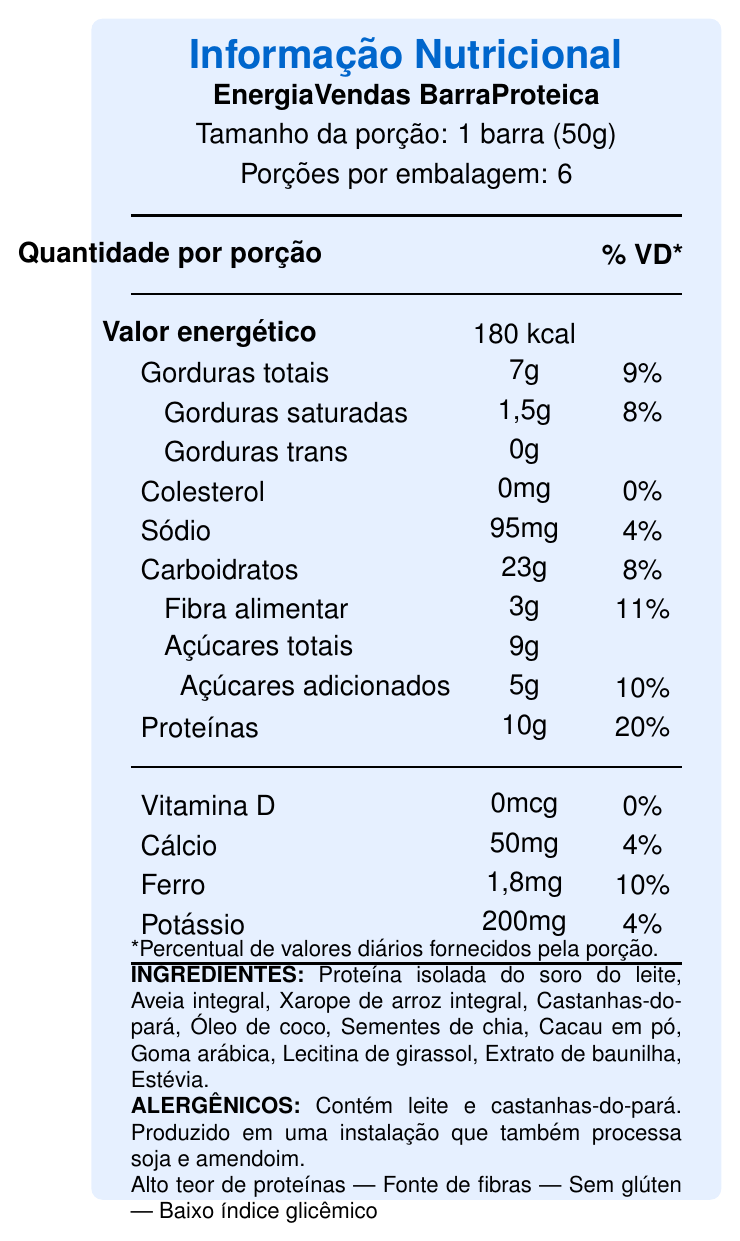what is the serving size of the EnergiaVendas BarraProteica? The serving size is mentioned at the top of the document stating "Tamanho da porção: 1 barra (50g)".
Answer: 1 barra (50g) how much protein does one serving of EnergiaVendas BarraProteica contain? The amount of protein per serving is listed as "Proteínas: 10g" in the document.
Answer: 10g what percentage of the daily value of dietary fiber does one serving of EnergiaVendas BarraProteica provide? The document shows "Fibra alimentar" as 3g, which corresponds to 11% of the daily value.
Answer: 11% does the EnergiaVendas BarraProteica contain any vitamin D? The document lists "Vitamina D: 0mcg" and indicates this provides 0% of the daily value, meaning it does not contain any vitamin D.
Answer: No what are the main allergens present in the EnergiaVendas BarraProteica? The allergens section states, "Contém leite e castanhas-do-pará".
Answer: Leite e castanhas-do-pará how many servings are there in one container? A. 4 B. 5 C. 6 D. 8 The document states "Porções por embalagem: 6".
Answer: C which of the following claims does the EnergiaVendas BarraProteica NOT make? A. Alto teor de proteínas B. Fonte de fibras C. Baixo teor de gordura D. Sem glúten The claims listed in the document are "Alto teor de proteínas", "Fonte de fibras", "Sem glúten", and "Baixo índice glicêmico", but not "Baixo teor de gordura".
Answer: C is the EnergiaVendas BarraProteica gluten-free? The document includes the claim "Sem glúten", indicating it is gluten-free.
Answer: Yes summarize the main benefits of consuming EnergiaVendas BarraProteica during long sales meetings. The document lists the benefits as "Fornece energia sustentável durante longas reuniões", "Ajuda a manter o foco e a concentração", "Promove saciedade sem causar sonolência", and "Prático para levar em viagens de negócios".
Answer: Provides sustainable energy, helps maintain focus, promotes satiety without sleepiness, and is convenient for business travel. what is the percentage of daily value for potassium contained in one serving? The document indicates "Potássio: 200mg" which corresponds to 4% of the daily value.
Answer: 4% what type of protein is used as an ingredient in EnergiaVendas BarraProteica? The ingredient list includes "Proteína isolada do soro do leite" as one of the components.
Answer: Proteína isolada do soro do leite does the EnergiaVendas BarraProteica contain any added sugars? The document indicates "Açúcares adicionados: 5g" representing 10% of the daily value.
Answer: Yes how should EnergiaVendas BarraProteica be stored? The storage instructions specify to keep it in a dry and cool place.
Answer: Conservar em local seco e fresco can you determine the exact expiry date of the EnergiaVendas BarraProteica from the document? The document does not provide details regarding the expiry date.
Answer: Not enough information 